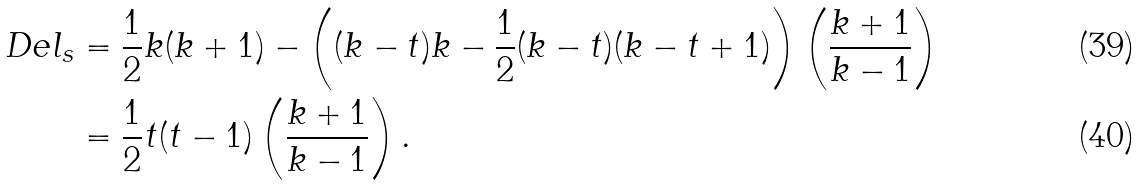Convert formula to latex. <formula><loc_0><loc_0><loc_500><loc_500>\ D e l _ { s } & = \frac { 1 } { 2 } k ( k + 1 ) - \left ( ( k - t ) k - \frac { 1 } { 2 } ( k - t ) ( k - t + 1 ) \right ) \left ( \frac { k + 1 } { k - 1 } \right ) \\ & = \frac { 1 } { 2 } t ( t - 1 ) \left ( \frac { k + 1 } { k - 1 } \right ) .</formula> 